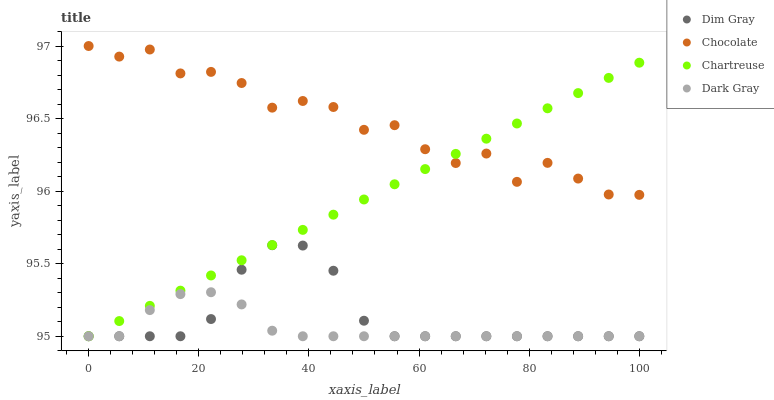Does Dark Gray have the minimum area under the curve?
Answer yes or no. Yes. Does Chocolate have the maximum area under the curve?
Answer yes or no. Yes. Does Chartreuse have the minimum area under the curve?
Answer yes or no. No. Does Chartreuse have the maximum area under the curve?
Answer yes or no. No. Is Chartreuse the smoothest?
Answer yes or no. Yes. Is Chocolate the roughest?
Answer yes or no. Yes. Is Dim Gray the smoothest?
Answer yes or no. No. Is Dim Gray the roughest?
Answer yes or no. No. Does Dark Gray have the lowest value?
Answer yes or no. Yes. Does Chocolate have the lowest value?
Answer yes or no. No. Does Chocolate have the highest value?
Answer yes or no. Yes. Does Chartreuse have the highest value?
Answer yes or no. No. Is Dark Gray less than Chocolate?
Answer yes or no. Yes. Is Chocolate greater than Dim Gray?
Answer yes or no. Yes. Does Chartreuse intersect Dim Gray?
Answer yes or no. Yes. Is Chartreuse less than Dim Gray?
Answer yes or no. No. Is Chartreuse greater than Dim Gray?
Answer yes or no. No. Does Dark Gray intersect Chocolate?
Answer yes or no. No. 